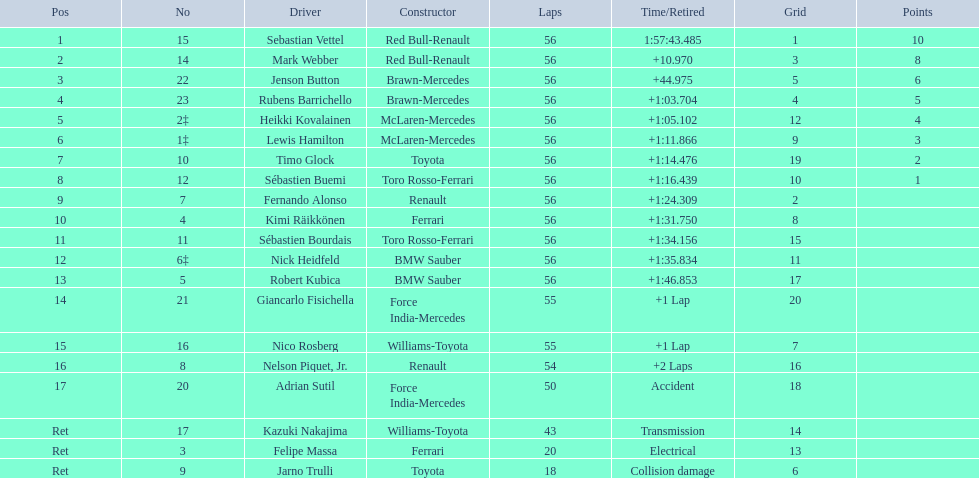How many laps in total is the race? 56. 